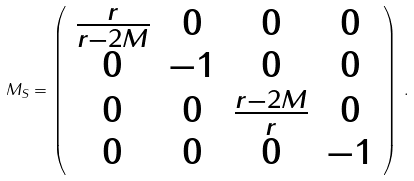Convert formula to latex. <formula><loc_0><loc_0><loc_500><loc_500>M _ { S } = \left ( \begin{array} { c c c c } \frac { r } { r - 2 M } & 0 & 0 & 0 \\ 0 & - 1 & 0 & 0 \\ 0 & 0 & \frac { r - 2 M } { r } & 0 \\ 0 & 0 & 0 & - 1 \end{array} \right ) \, .</formula> 